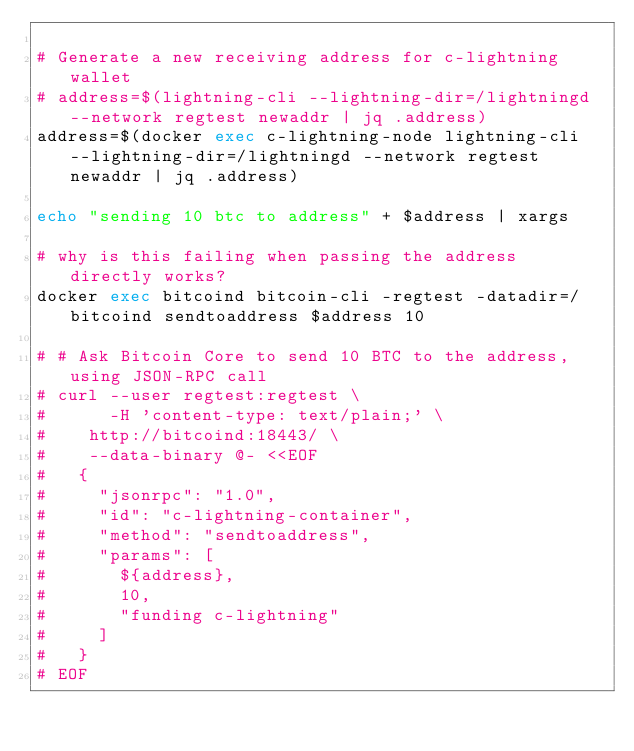Convert code to text. <code><loc_0><loc_0><loc_500><loc_500><_Bash_>
# Generate a new receiving address for c-lightning wallet
# address=$(lightning-cli --lightning-dir=/lightningd --network regtest newaddr | jq .address)
address=$(docker exec c-lightning-node lightning-cli --lightning-dir=/lightningd --network regtest newaddr | jq .address)

echo "sending 10 btc to address" + $address | xargs

# why is this failing when passing the address directly works?
docker exec bitcoind bitcoin-cli -regtest -datadir=/bitcoind sendtoaddress $address 10

# # Ask Bitcoin Core to send 10 BTC to the address, using JSON-RPC call
# curl --user regtest:regtest \
#      -H 'content-type: text/plain;' \
# 	 http://bitcoind:18443/ \
# 	 --data-binary @- <<EOF
# 	{
# 	  "jsonrpc": "1.0",
# 	  "id": "c-lightning-container",
# 	  "method": "sendtoaddress",
# 	  "params": [
# 	    ${address},
# 	    10,
# 	    "funding c-lightning"
# 	  ]
# 	}
# EOF
</code> 